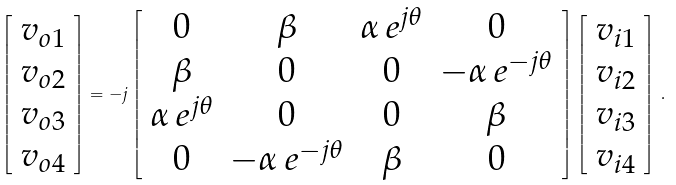Convert formula to latex. <formula><loc_0><loc_0><loc_500><loc_500>\left [ \begin{array} { c } v _ { o 1 } \\ v _ { o 2 } \\ v _ { o 3 } \\ v _ { o 4 } \end{array} \right ] = - j \left [ \begin{array} { c c c c } 0 & \beta & \alpha \, e ^ { j \theta } & 0 \\ \beta & 0 & 0 & - \alpha \, e ^ { - j \theta } \\ \alpha \, e ^ { j \theta } & 0 & 0 & \beta \\ 0 & - \alpha \, e ^ { - j \theta } & \beta & 0 \end{array} \right ] \left [ \begin{array} { c } v _ { i 1 } \\ v _ { i 2 } \\ v _ { i 3 } \\ v _ { i 4 } \end{array} \right ] \, .</formula> 